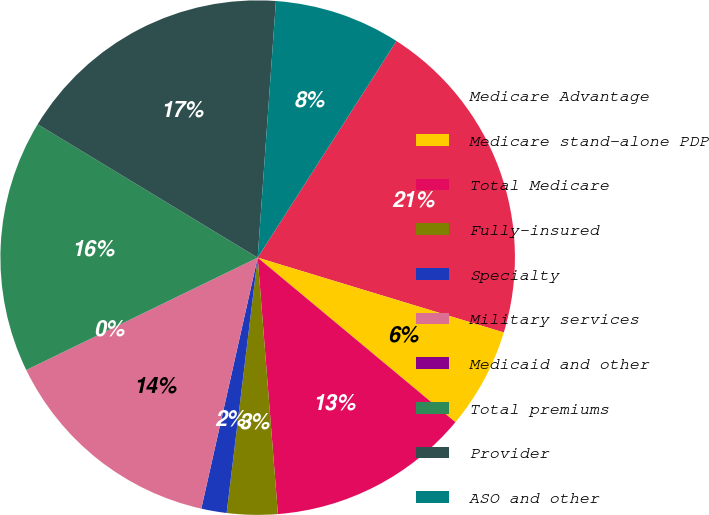Convert chart. <chart><loc_0><loc_0><loc_500><loc_500><pie_chart><fcel>Medicare Advantage<fcel>Medicare stand-alone PDP<fcel>Total Medicare<fcel>Fully-insured<fcel>Specialty<fcel>Military services<fcel>Medicaid and other<fcel>Total premiums<fcel>Provider<fcel>ASO and other<nl><fcel>20.63%<fcel>6.35%<fcel>12.7%<fcel>3.18%<fcel>1.59%<fcel>14.29%<fcel>0.0%<fcel>15.87%<fcel>17.46%<fcel>7.94%<nl></chart> 